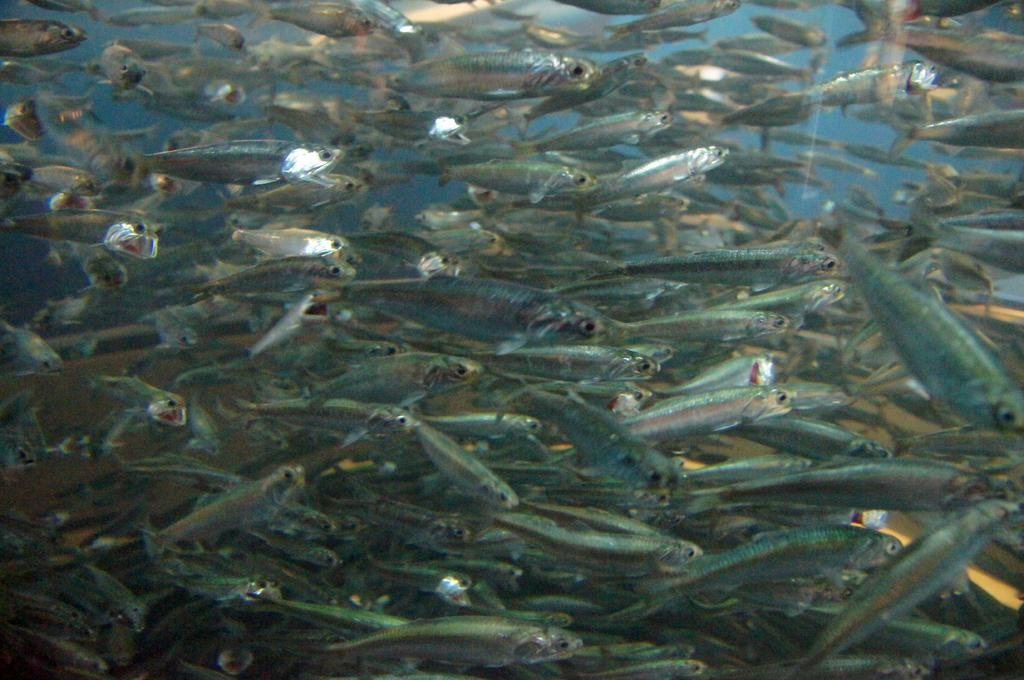What type of animals can be seen in the image? There are small fishes in the image. Where are the fishes located? The fishes are in a water body. What invention is being demonstrated by the fishes in the image? There is no invention being demonstrated by the fishes in the image; they are simply swimming in the water body. 